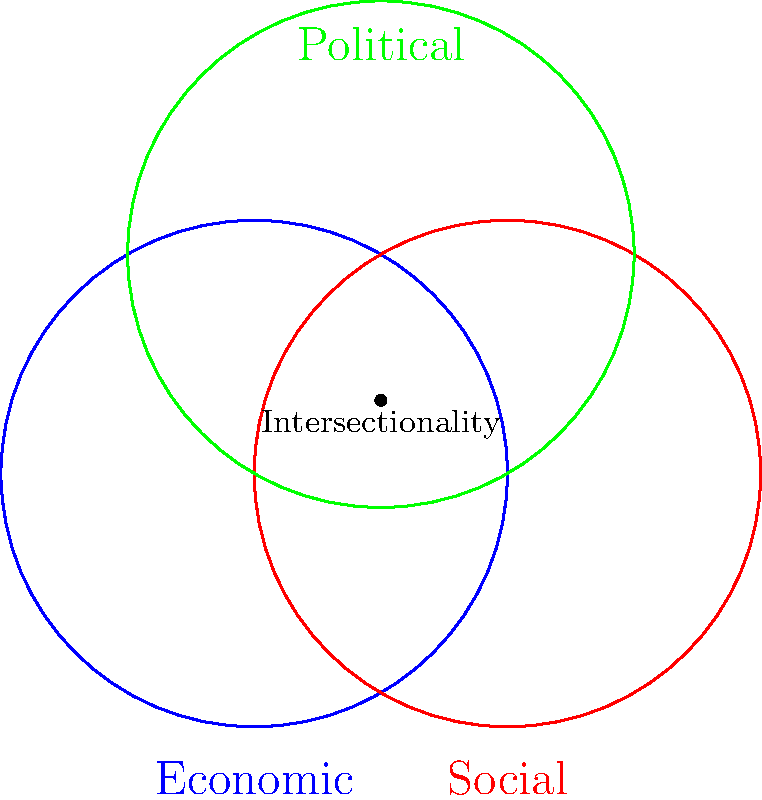Consider the manifold $M$ formed by the intersection of three circles representing economic, social, and political aspects of feminism, as shown in the diagram. What is the fundamental group $\pi_1(M)$ of this manifold, and how does it relate to the intersectionality of feminism? To determine the fundamental group of the manifold $M$, we'll follow these steps:

1. Identify the shape: The intersection of three circles forms a shape known as the Borromean rings.

2. Analyze the topology: The Borromean rings create a planar graph with 7 vertices, 12 edges, and 6 faces.

3. Apply Euler's formula: $V - E + F = 2$, where $V=7$, $E=12$, and $F=6$. This confirms that the manifold is homeomorphic to a sphere with holes.

4. Count the holes: There are 3 holes in the manifold, one for each circle.

5. Determine the fundamental group: For a sphere with $n$ holes, the fundamental group is the free group on $n$ generators. In this case, $n=3$.

6. Express the fundamental group: $\pi_1(M) \cong F_3$, where $F_3$ is the free group on 3 generators.

Relating to intersectionality:
- Each generator represents one aspect of feminism (economic, social, political).
- The free group structure indicates that these aspects can be combined in any order and with any frequency.
- The non-commutativity of the free group reflects how the order of addressing these aspects can lead to different outcomes in feminist theory and practice.
- The interconnectedness of the rings in the Borromean configuration symbolizes how these aspects are intrinsically linked in intersectional feminism.
Answer: $\pi_1(M) \cong F_3$ 